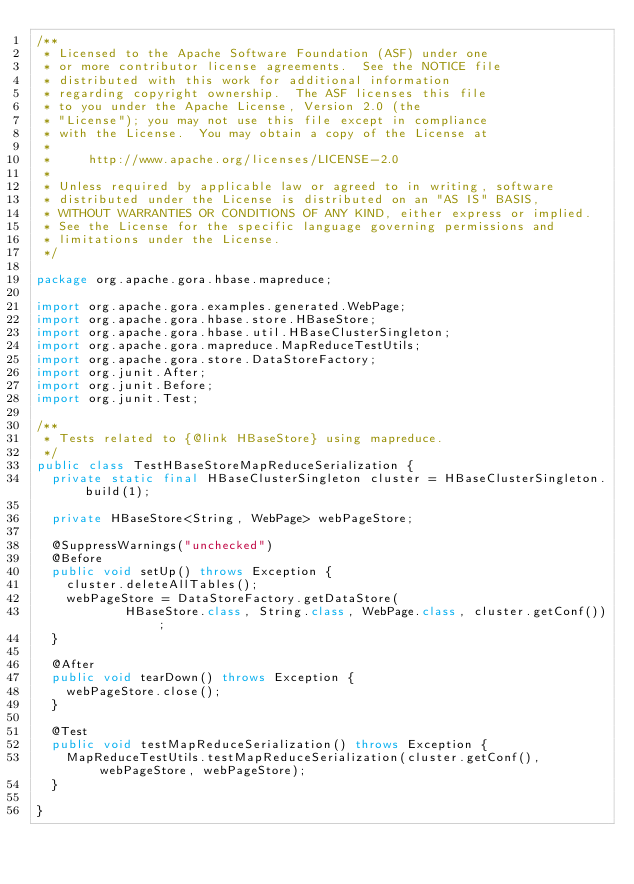<code> <loc_0><loc_0><loc_500><loc_500><_Java_>/**
 * Licensed to the Apache Software Foundation (ASF) under one
 * or more contributor license agreements.  See the NOTICE file
 * distributed with this work for additional information
 * regarding copyright ownership.  The ASF licenses this file
 * to you under the Apache License, Version 2.0 (the
 * "License"); you may not use this file except in compliance
 * with the License.  You may obtain a copy of the License at
 *
 *     http://www.apache.org/licenses/LICENSE-2.0
 *
 * Unless required by applicable law or agreed to in writing, software
 * distributed under the License is distributed on an "AS IS" BASIS,
 * WITHOUT WARRANTIES OR CONDITIONS OF ANY KIND, either express or implied.
 * See the License for the specific language governing permissions and
 * limitations under the License.
 */

package org.apache.gora.hbase.mapreduce;

import org.apache.gora.examples.generated.WebPage;
import org.apache.gora.hbase.store.HBaseStore;
import org.apache.gora.hbase.util.HBaseClusterSingleton;
import org.apache.gora.mapreduce.MapReduceTestUtils;
import org.apache.gora.store.DataStoreFactory;
import org.junit.After;
import org.junit.Before;
import org.junit.Test;

/**
 * Tests related to {@link HBaseStore} using mapreduce.
 */
public class TestHBaseStoreMapReduceSerialization {
  private static final HBaseClusterSingleton cluster = HBaseClusterSingleton.build(1);

  private HBaseStore<String, WebPage> webPageStore;

  @SuppressWarnings("unchecked")
  @Before
  public void setUp() throws Exception {
    cluster.deleteAllTables();
    webPageStore = DataStoreFactory.getDataStore(
            HBaseStore.class, String.class, WebPage.class, cluster.getConf());
  }

  @After
  public void tearDown() throws Exception {
    webPageStore.close();
  }

  @Test
  public void testMapReduceSerialization() throws Exception {
    MapReduceTestUtils.testMapReduceSerialization(cluster.getConf(), webPageStore, webPageStore);
  }

}</code> 